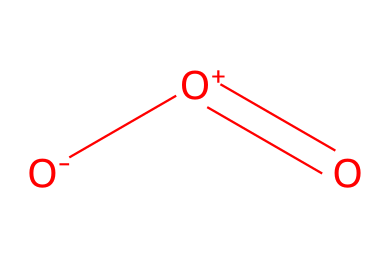What is the molecular formula of this chemical? The SMILES representation shows three oxygen atoms (O) bonded in a specific arrangement. Counting the oxygen atoms, we determine the molecular formula is O3.
Answer: O3 How many double bonds are present in this chemical structure? In the SMILES representation, there is one double bond indicated between the central oxygen atom and one of the other oxygen atoms (the [O+]=O), making it a total of one double bond.
Answer: one What type of molecule is represented by this structure? The structure corresponds to a gas that occurs in the atmosphere, specifically as a triatomic molecule composed entirely of oxygen atoms. Ozone is known to be a gas at room temperature.
Answer: gas What effect does ozone have on outdoor photographs? Ozone is known to have a detrimental effect on outdoor photographs as it can cause fading and degradation of colors in photographic materials due to its oxidative properties.
Answer: fading How does the number of oxygen atoms relate to the reactivity of ozone? The presence of three oxygen atoms contributes to ozone's higher reactivity compared to diatomic molecules like O2, as the structure allows it to participate in various chemical reactions, particularly as an oxidizing agent.
Answer: reactivity What distinguishes ozone from regular oxygen? Ozone's three-atom structure ([O-][O+]=O) allows it to absorb more UV radiation compared to regular diatomic oxygen (O2), impacting its functionality and role in the atmosphere.
Answer: three-atom structure 